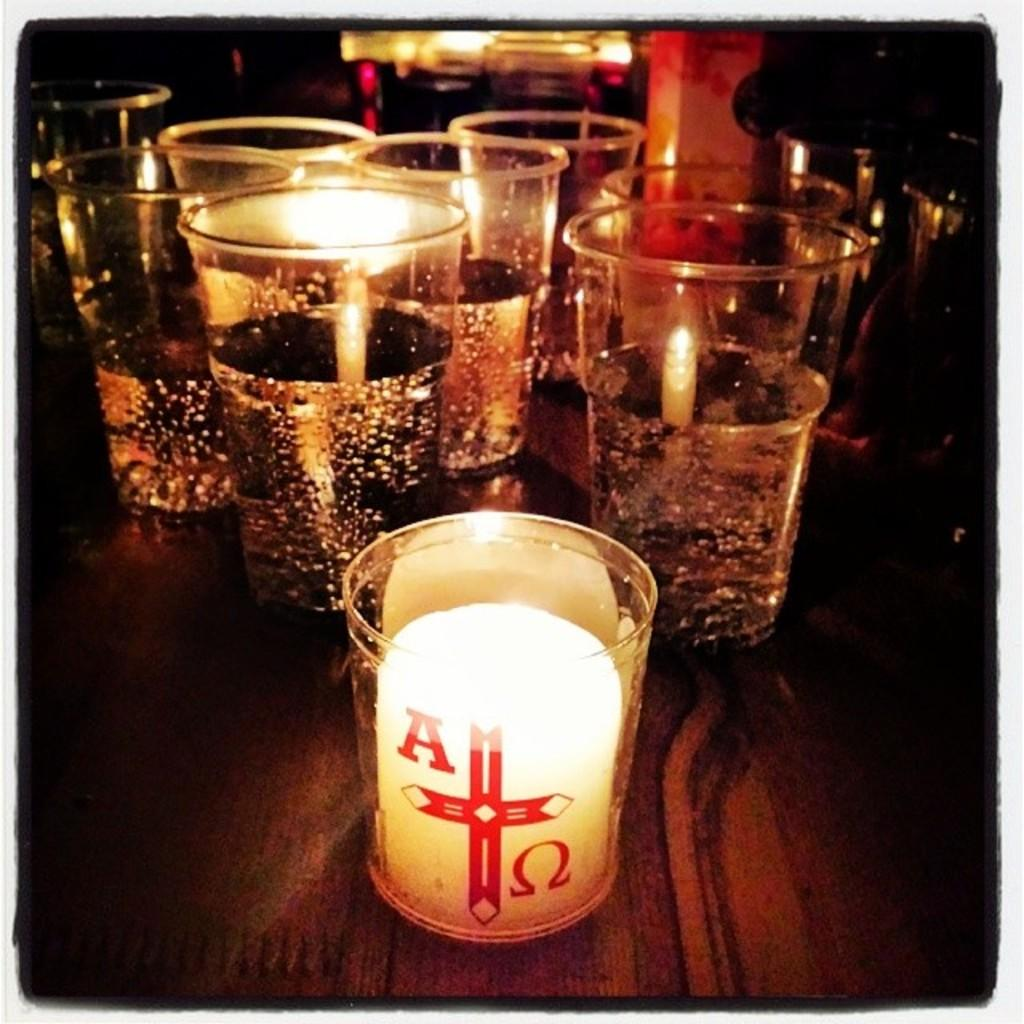<image>
Create a compact narrative representing the image presented. A lit candle with an A and Omega symbol in front of some glasses 